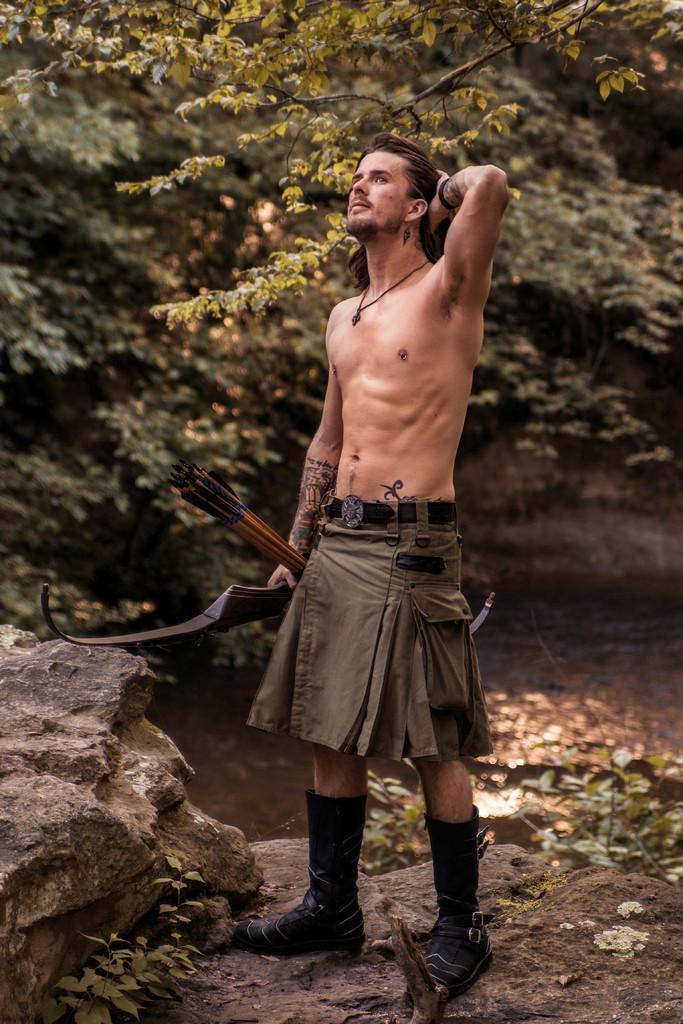How would you summarize this image in a sentence or two? In this image we can see a person standing and holding the objects, there are some trees, plants, rocks and water. 